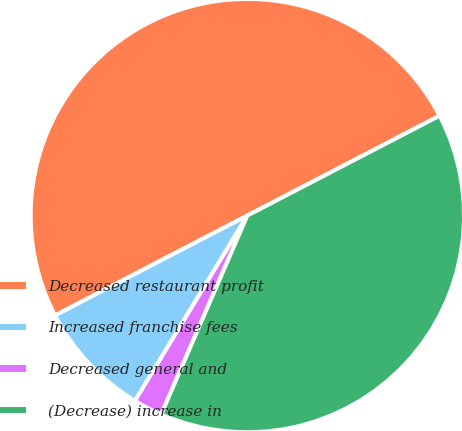Convert chart. <chart><loc_0><loc_0><loc_500><loc_500><pie_chart><fcel>Decreased restaurant profit<fcel>Increased franchise fees<fcel>Decreased general and<fcel>(Decrease) increase in<nl><fcel>50.0%<fcel>8.7%<fcel>2.17%<fcel>39.13%<nl></chart> 